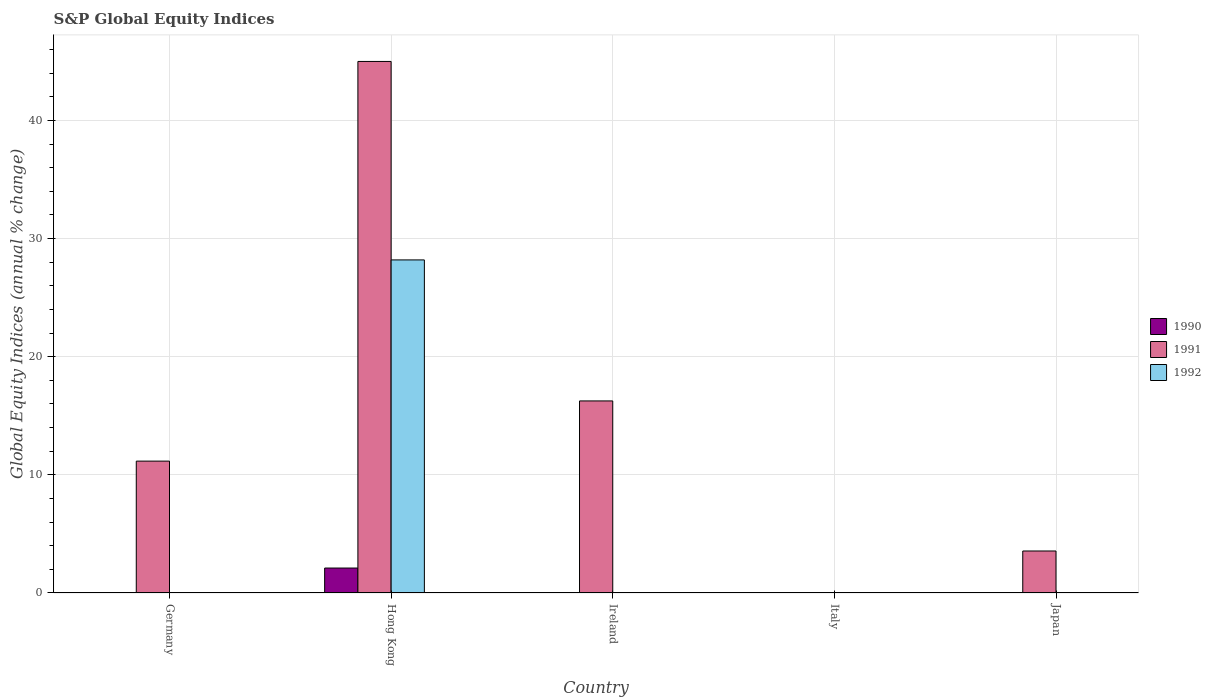Are the number of bars per tick equal to the number of legend labels?
Make the answer very short. No. How many bars are there on the 1st tick from the right?
Keep it short and to the point. 1. What is the label of the 3rd group of bars from the left?
Provide a short and direct response. Ireland. In how many cases, is the number of bars for a given country not equal to the number of legend labels?
Make the answer very short. 4. What is the global equity indices in 1990 in Hong Kong?
Make the answer very short. 2.11. Across all countries, what is the maximum global equity indices in 1991?
Make the answer very short. 44.99. Across all countries, what is the minimum global equity indices in 1991?
Provide a succinct answer. 0. In which country was the global equity indices in 1991 maximum?
Offer a very short reply. Hong Kong. What is the total global equity indices in 1992 in the graph?
Your answer should be compact. 28.19. What is the difference between the global equity indices in 1991 in Ireland and that in Japan?
Offer a terse response. 12.7. What is the difference between the global equity indices in 1991 in Ireland and the global equity indices in 1992 in Hong Kong?
Give a very brief answer. -11.94. What is the average global equity indices in 1990 per country?
Give a very brief answer. 0.42. What is the difference between the global equity indices of/in 1991 and global equity indices of/in 1992 in Hong Kong?
Offer a terse response. 16.8. What is the ratio of the global equity indices in 1991 in Germany to that in Japan?
Offer a very short reply. 3.14. What is the difference between the highest and the second highest global equity indices in 1991?
Keep it short and to the point. 5.09. What is the difference between the highest and the lowest global equity indices in 1991?
Provide a short and direct response. 44.99. Is it the case that in every country, the sum of the global equity indices in 1992 and global equity indices in 1990 is greater than the global equity indices in 1991?
Give a very brief answer. No. Are all the bars in the graph horizontal?
Provide a succinct answer. No. How many countries are there in the graph?
Keep it short and to the point. 5. What is the difference between two consecutive major ticks on the Y-axis?
Ensure brevity in your answer.  10. Are the values on the major ticks of Y-axis written in scientific E-notation?
Your answer should be very brief. No. Does the graph contain any zero values?
Offer a terse response. Yes. Does the graph contain grids?
Keep it short and to the point. Yes. How many legend labels are there?
Ensure brevity in your answer.  3. What is the title of the graph?
Offer a very short reply. S&P Global Equity Indices. What is the label or title of the X-axis?
Keep it short and to the point. Country. What is the label or title of the Y-axis?
Offer a very short reply. Global Equity Indices (annual % change). What is the Global Equity Indices (annual % change) in 1990 in Germany?
Keep it short and to the point. 0. What is the Global Equity Indices (annual % change) in 1991 in Germany?
Your answer should be very brief. 11.16. What is the Global Equity Indices (annual % change) in 1990 in Hong Kong?
Make the answer very short. 2.11. What is the Global Equity Indices (annual % change) of 1991 in Hong Kong?
Ensure brevity in your answer.  44.99. What is the Global Equity Indices (annual % change) in 1992 in Hong Kong?
Provide a short and direct response. 28.19. What is the Global Equity Indices (annual % change) of 1990 in Ireland?
Your response must be concise. 0. What is the Global Equity Indices (annual % change) in 1991 in Ireland?
Your response must be concise. 16.26. What is the Global Equity Indices (annual % change) in 1992 in Ireland?
Your answer should be very brief. 0. What is the Global Equity Indices (annual % change) of 1991 in Italy?
Your answer should be very brief. 0. What is the Global Equity Indices (annual % change) of 1992 in Italy?
Provide a succinct answer. 0. What is the Global Equity Indices (annual % change) of 1991 in Japan?
Ensure brevity in your answer.  3.55. What is the Global Equity Indices (annual % change) of 1992 in Japan?
Provide a short and direct response. 0. Across all countries, what is the maximum Global Equity Indices (annual % change) of 1990?
Offer a very short reply. 2.11. Across all countries, what is the maximum Global Equity Indices (annual % change) of 1991?
Keep it short and to the point. 44.99. Across all countries, what is the maximum Global Equity Indices (annual % change) in 1992?
Provide a succinct answer. 28.19. Across all countries, what is the minimum Global Equity Indices (annual % change) in 1990?
Your answer should be very brief. 0. Across all countries, what is the minimum Global Equity Indices (annual % change) of 1991?
Give a very brief answer. 0. What is the total Global Equity Indices (annual % change) in 1990 in the graph?
Offer a very short reply. 2.11. What is the total Global Equity Indices (annual % change) in 1991 in the graph?
Provide a succinct answer. 75.97. What is the total Global Equity Indices (annual % change) of 1992 in the graph?
Keep it short and to the point. 28.19. What is the difference between the Global Equity Indices (annual % change) of 1991 in Germany and that in Hong Kong?
Keep it short and to the point. -33.83. What is the difference between the Global Equity Indices (annual % change) of 1991 in Germany and that in Ireland?
Your response must be concise. -5.09. What is the difference between the Global Equity Indices (annual % change) in 1991 in Germany and that in Japan?
Your response must be concise. 7.61. What is the difference between the Global Equity Indices (annual % change) of 1991 in Hong Kong and that in Ireland?
Offer a terse response. 28.74. What is the difference between the Global Equity Indices (annual % change) of 1991 in Hong Kong and that in Japan?
Provide a short and direct response. 41.44. What is the difference between the Global Equity Indices (annual % change) of 1991 in Ireland and that in Japan?
Offer a very short reply. 12.7. What is the difference between the Global Equity Indices (annual % change) in 1991 in Germany and the Global Equity Indices (annual % change) in 1992 in Hong Kong?
Offer a very short reply. -17.03. What is the difference between the Global Equity Indices (annual % change) in 1990 in Hong Kong and the Global Equity Indices (annual % change) in 1991 in Ireland?
Give a very brief answer. -14.14. What is the difference between the Global Equity Indices (annual % change) in 1990 in Hong Kong and the Global Equity Indices (annual % change) in 1991 in Japan?
Your answer should be compact. -1.44. What is the average Global Equity Indices (annual % change) of 1990 per country?
Make the answer very short. 0.42. What is the average Global Equity Indices (annual % change) in 1991 per country?
Your answer should be very brief. 15.19. What is the average Global Equity Indices (annual % change) of 1992 per country?
Offer a very short reply. 5.64. What is the difference between the Global Equity Indices (annual % change) in 1990 and Global Equity Indices (annual % change) in 1991 in Hong Kong?
Provide a short and direct response. -42.88. What is the difference between the Global Equity Indices (annual % change) in 1990 and Global Equity Indices (annual % change) in 1992 in Hong Kong?
Your answer should be very brief. -26.08. What is the difference between the Global Equity Indices (annual % change) of 1991 and Global Equity Indices (annual % change) of 1992 in Hong Kong?
Provide a short and direct response. 16.8. What is the ratio of the Global Equity Indices (annual % change) in 1991 in Germany to that in Hong Kong?
Provide a short and direct response. 0.25. What is the ratio of the Global Equity Indices (annual % change) in 1991 in Germany to that in Ireland?
Your answer should be very brief. 0.69. What is the ratio of the Global Equity Indices (annual % change) in 1991 in Germany to that in Japan?
Offer a terse response. 3.14. What is the ratio of the Global Equity Indices (annual % change) in 1991 in Hong Kong to that in Ireland?
Keep it short and to the point. 2.77. What is the ratio of the Global Equity Indices (annual % change) of 1991 in Hong Kong to that in Japan?
Keep it short and to the point. 12.66. What is the ratio of the Global Equity Indices (annual % change) in 1991 in Ireland to that in Japan?
Your answer should be very brief. 4.57. What is the difference between the highest and the second highest Global Equity Indices (annual % change) in 1991?
Provide a short and direct response. 28.74. What is the difference between the highest and the lowest Global Equity Indices (annual % change) in 1990?
Your answer should be compact. 2.11. What is the difference between the highest and the lowest Global Equity Indices (annual % change) of 1991?
Provide a short and direct response. 44.99. What is the difference between the highest and the lowest Global Equity Indices (annual % change) in 1992?
Your response must be concise. 28.19. 